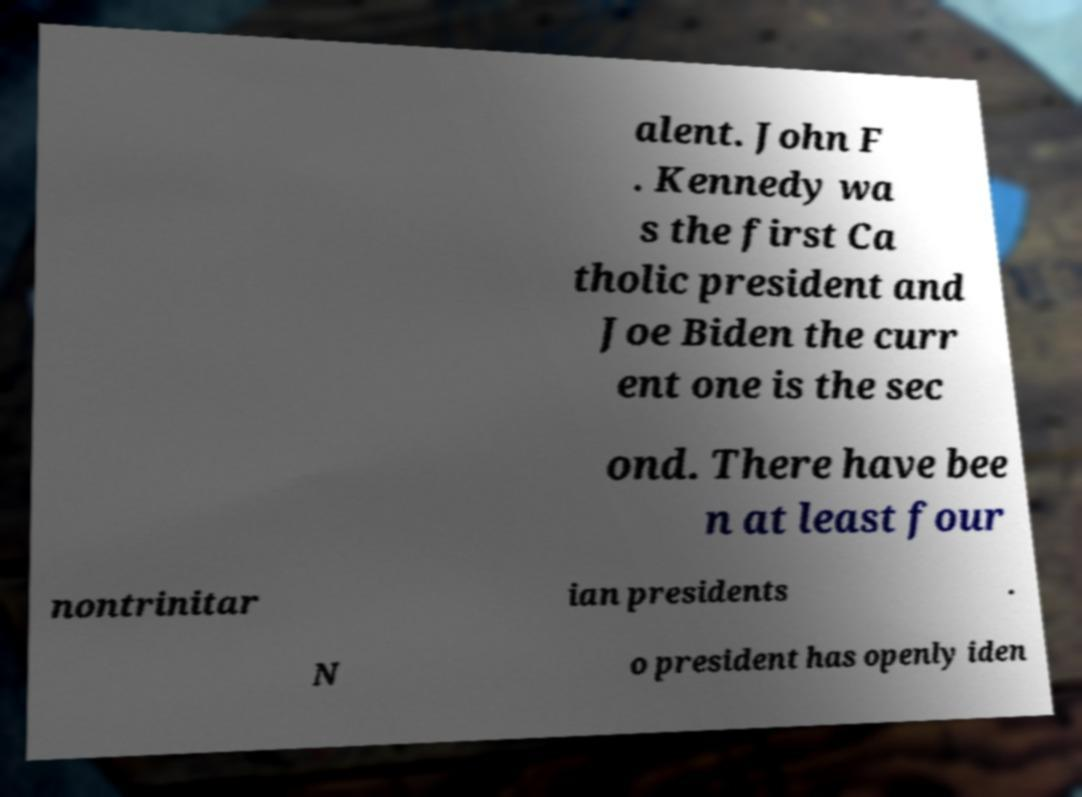Can you read and provide the text displayed in the image?This photo seems to have some interesting text. Can you extract and type it out for me? alent. John F . Kennedy wa s the first Ca tholic president and Joe Biden the curr ent one is the sec ond. There have bee n at least four nontrinitar ian presidents . N o president has openly iden 